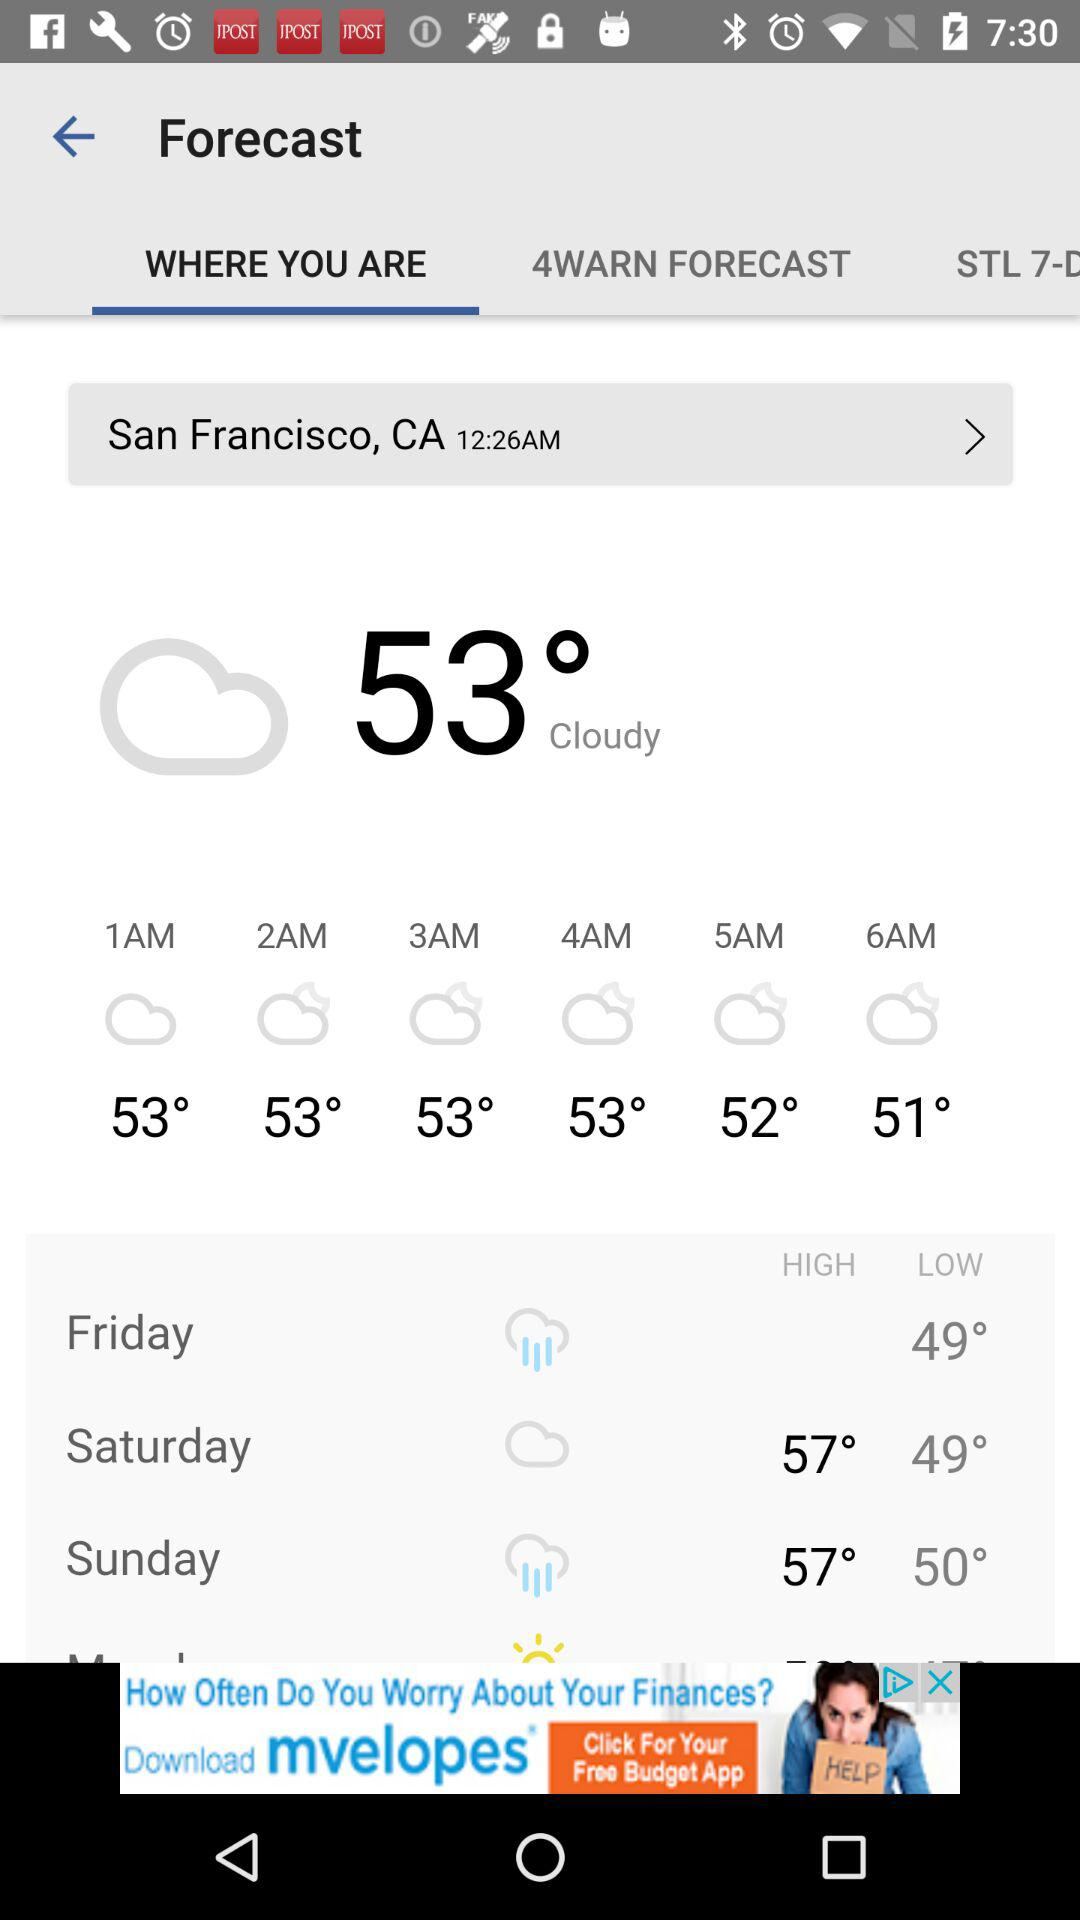How many days are included in the forecast?
Answer the question using a single word or phrase. 3 